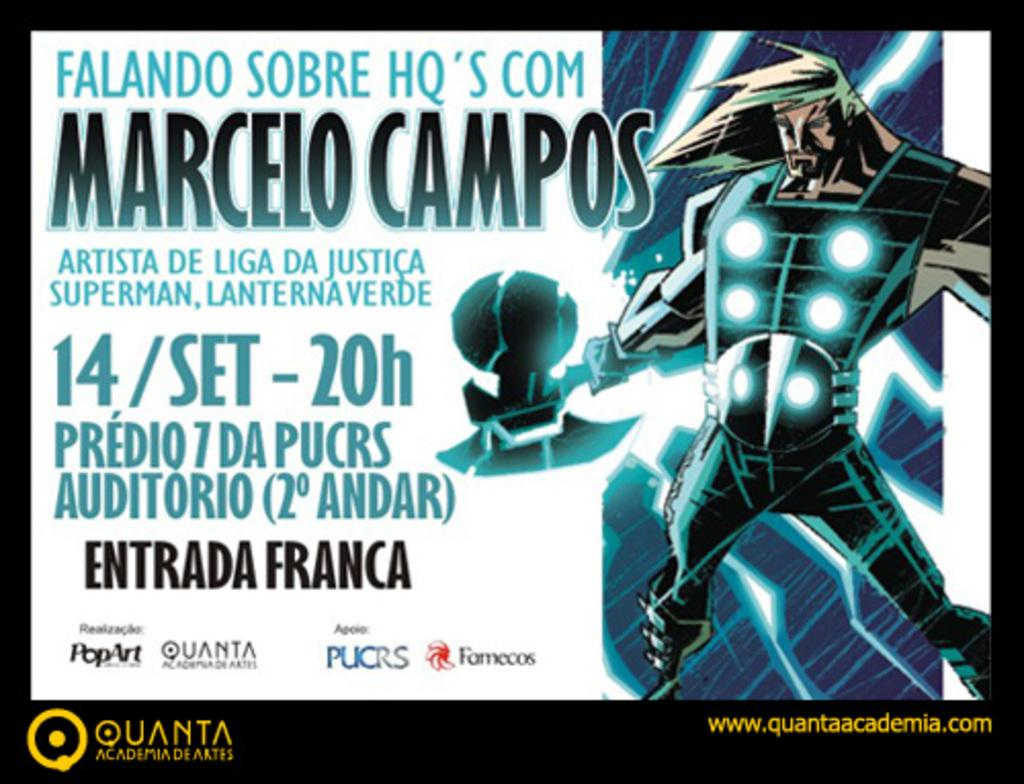<image>
Create a compact narrative representing the image presented. A poster for an event called Marcelo Campos. 